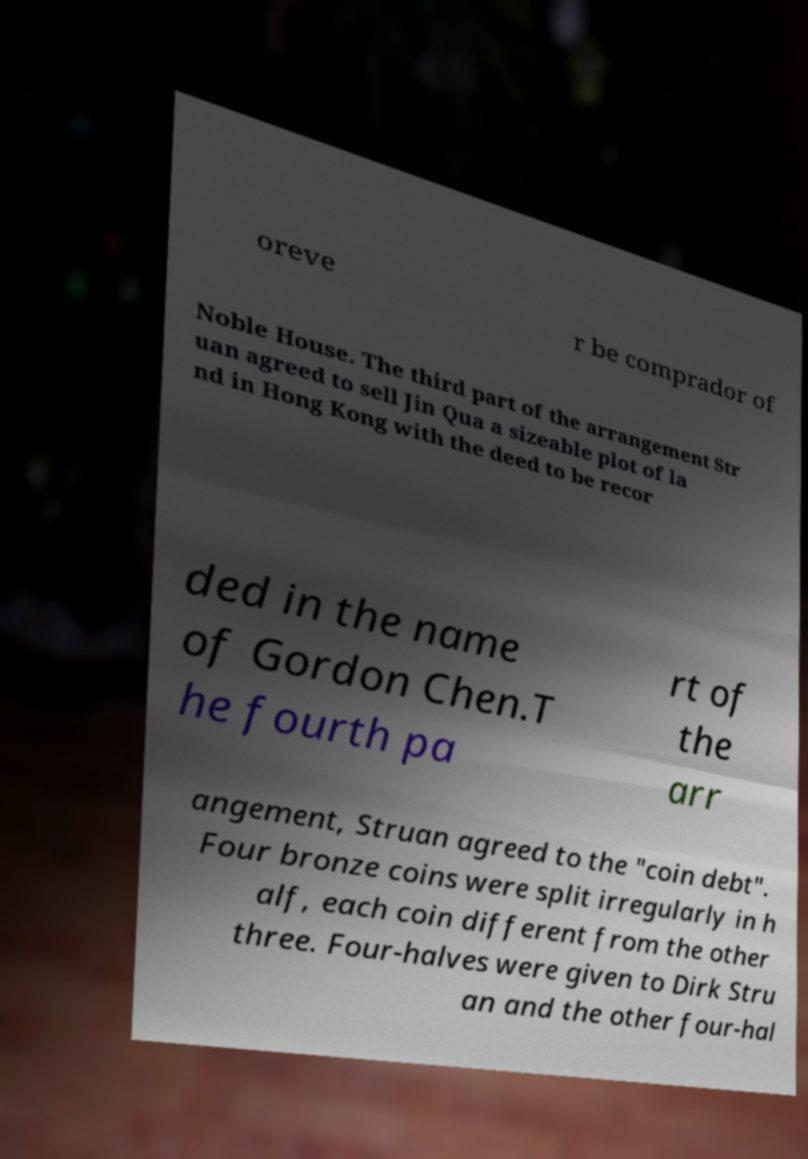Can you accurately transcribe the text from the provided image for me? oreve r be comprador of Noble House. The third part of the arrangement Str uan agreed to sell Jin Qua a sizeable plot of la nd in Hong Kong with the deed to be recor ded in the name of Gordon Chen.T he fourth pa rt of the arr angement, Struan agreed to the "coin debt". Four bronze coins were split irregularly in h alf, each coin different from the other three. Four-halves were given to Dirk Stru an and the other four-hal 